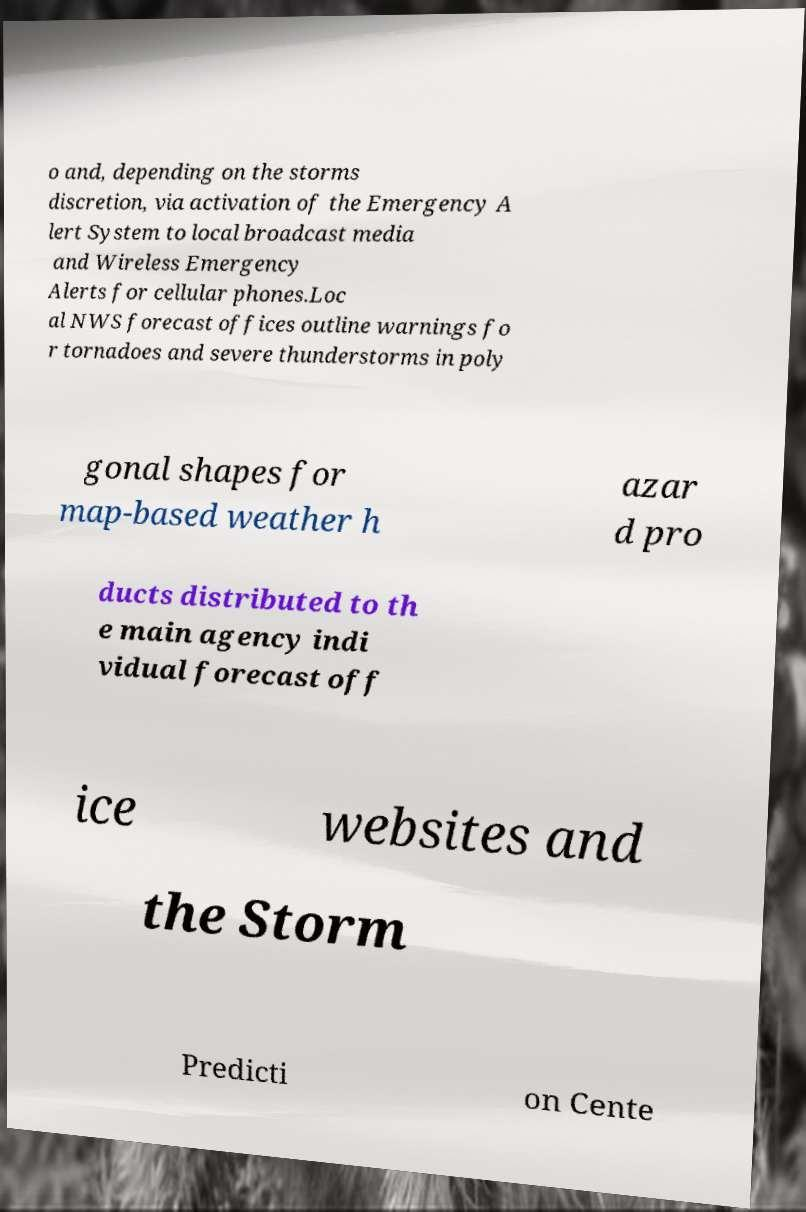Could you assist in decoding the text presented in this image and type it out clearly? o and, depending on the storms discretion, via activation of the Emergency A lert System to local broadcast media and Wireless Emergency Alerts for cellular phones.Loc al NWS forecast offices outline warnings fo r tornadoes and severe thunderstorms in poly gonal shapes for map-based weather h azar d pro ducts distributed to th e main agency indi vidual forecast off ice websites and the Storm Predicti on Cente 